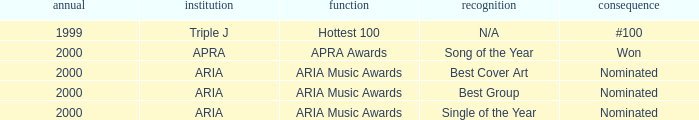What's the award for #100? N/A. 